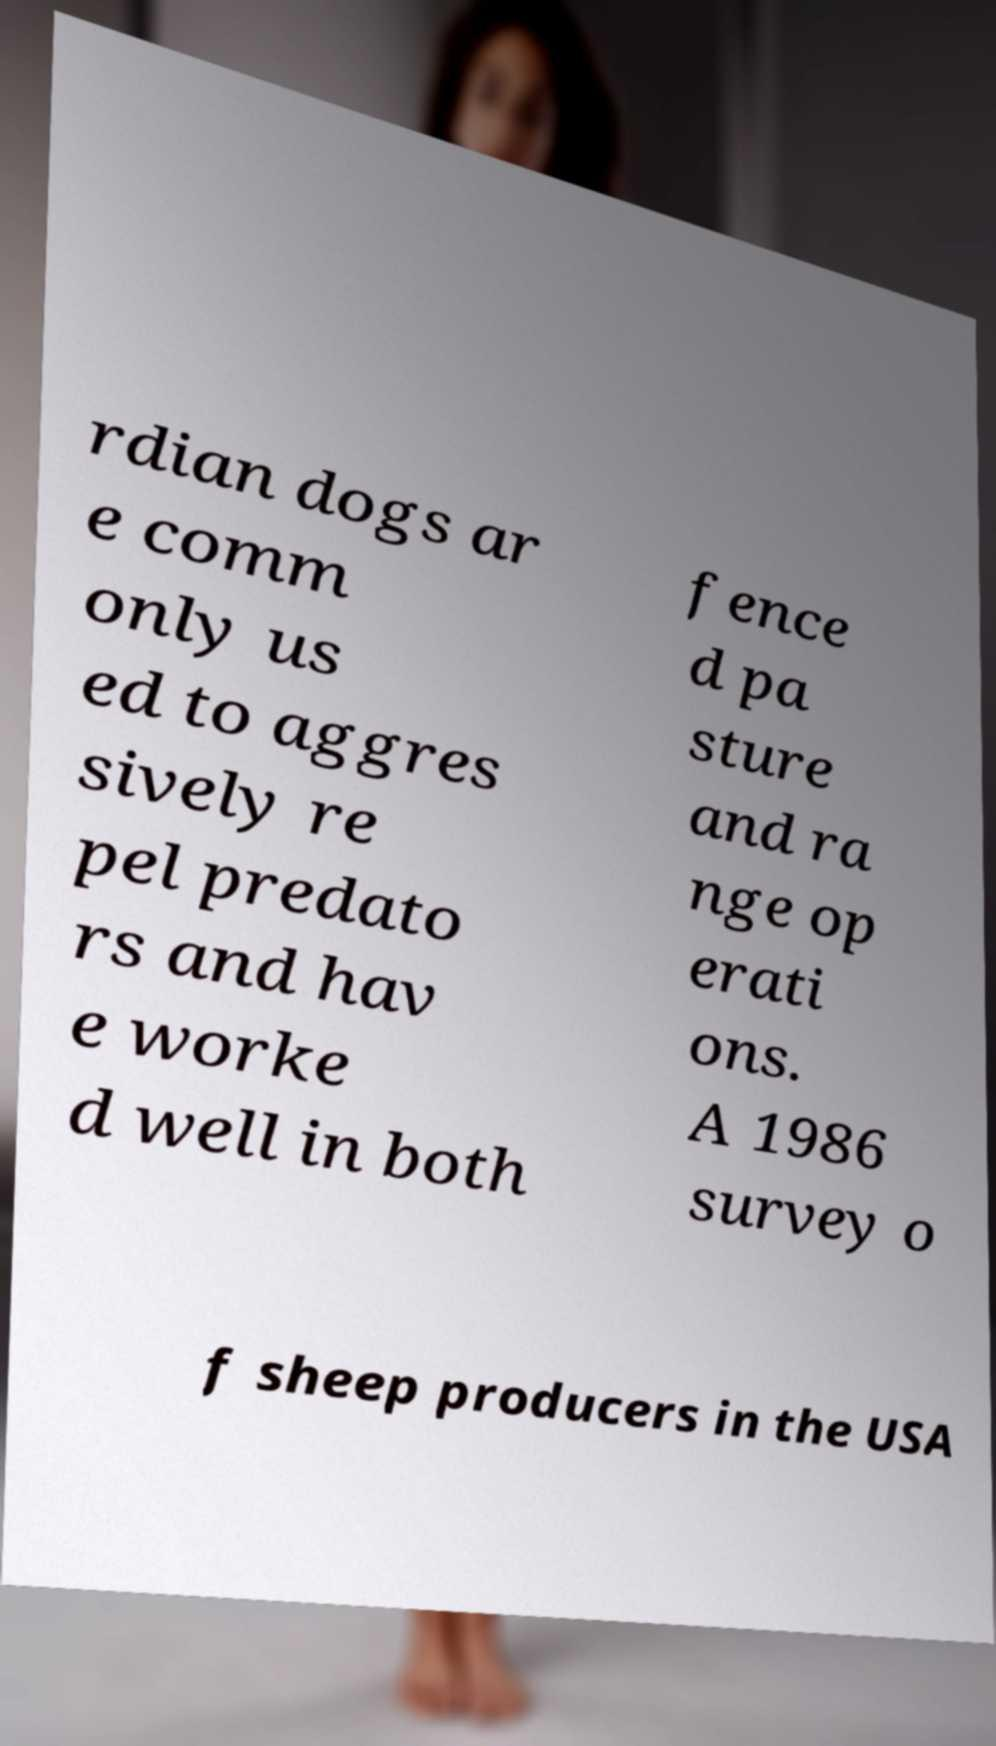Can you accurately transcribe the text from the provided image for me? rdian dogs ar e comm only us ed to aggres sively re pel predato rs and hav e worke d well in both fence d pa sture and ra nge op erati ons. A 1986 survey o f sheep producers in the USA 